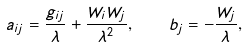Convert formula to latex. <formula><loc_0><loc_0><loc_500><loc_500>a _ { i j } = \frac { g _ { i j } } { \lambda } + \frac { W _ { i } W _ { j } } { \lambda ^ { 2 } } , \quad b _ { j } = - \frac { W _ { j } } { \lambda } ,</formula> 